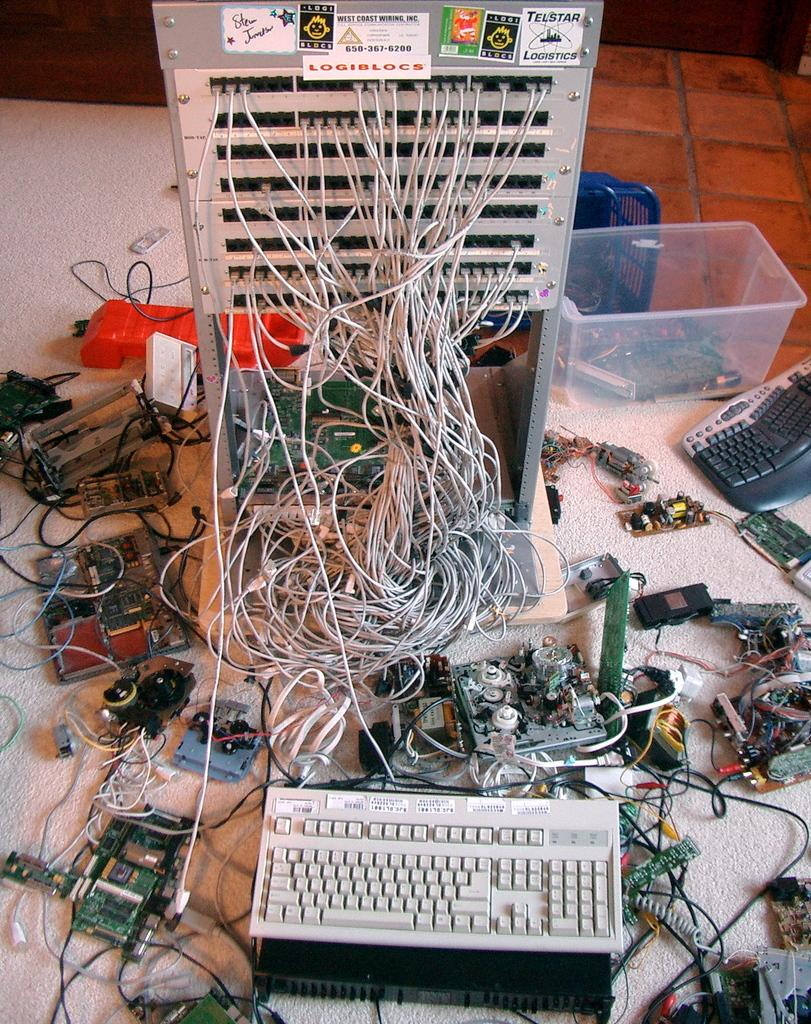What type of electronic device is visible in the image? There is an electronic device in the image, but the specific type is not mentioned. What is the color of the surface where the objects are placed? The surface where the objects are placed is white. What is one of the objects on the white surface? There is a keyboard in the image. What is the opinion of the snakes about the electronic device in the image? There are no snakes present in the image, so it is not possible to determine their opinion about the electronic device. 